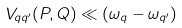Convert formula to latex. <formula><loc_0><loc_0><loc_500><loc_500>V _ { q q ^ { \prime } } ( P , Q ) \ll ( \omega _ { q } - \omega _ { q ^ { \prime } } )</formula> 